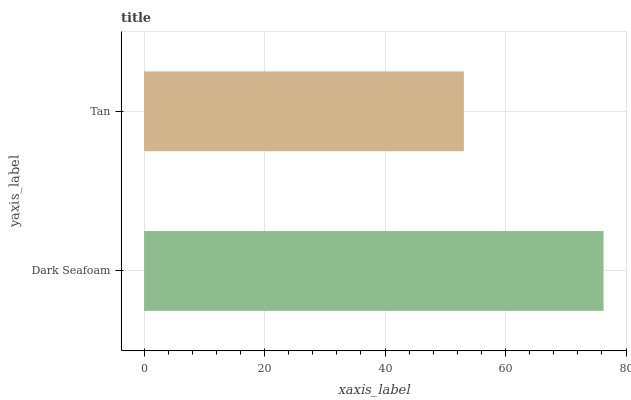Is Tan the minimum?
Answer yes or no. Yes. Is Dark Seafoam the maximum?
Answer yes or no. Yes. Is Tan the maximum?
Answer yes or no. No. Is Dark Seafoam greater than Tan?
Answer yes or no. Yes. Is Tan less than Dark Seafoam?
Answer yes or no. Yes. Is Tan greater than Dark Seafoam?
Answer yes or no. No. Is Dark Seafoam less than Tan?
Answer yes or no. No. Is Dark Seafoam the high median?
Answer yes or no. Yes. Is Tan the low median?
Answer yes or no. Yes. Is Tan the high median?
Answer yes or no. No. Is Dark Seafoam the low median?
Answer yes or no. No. 